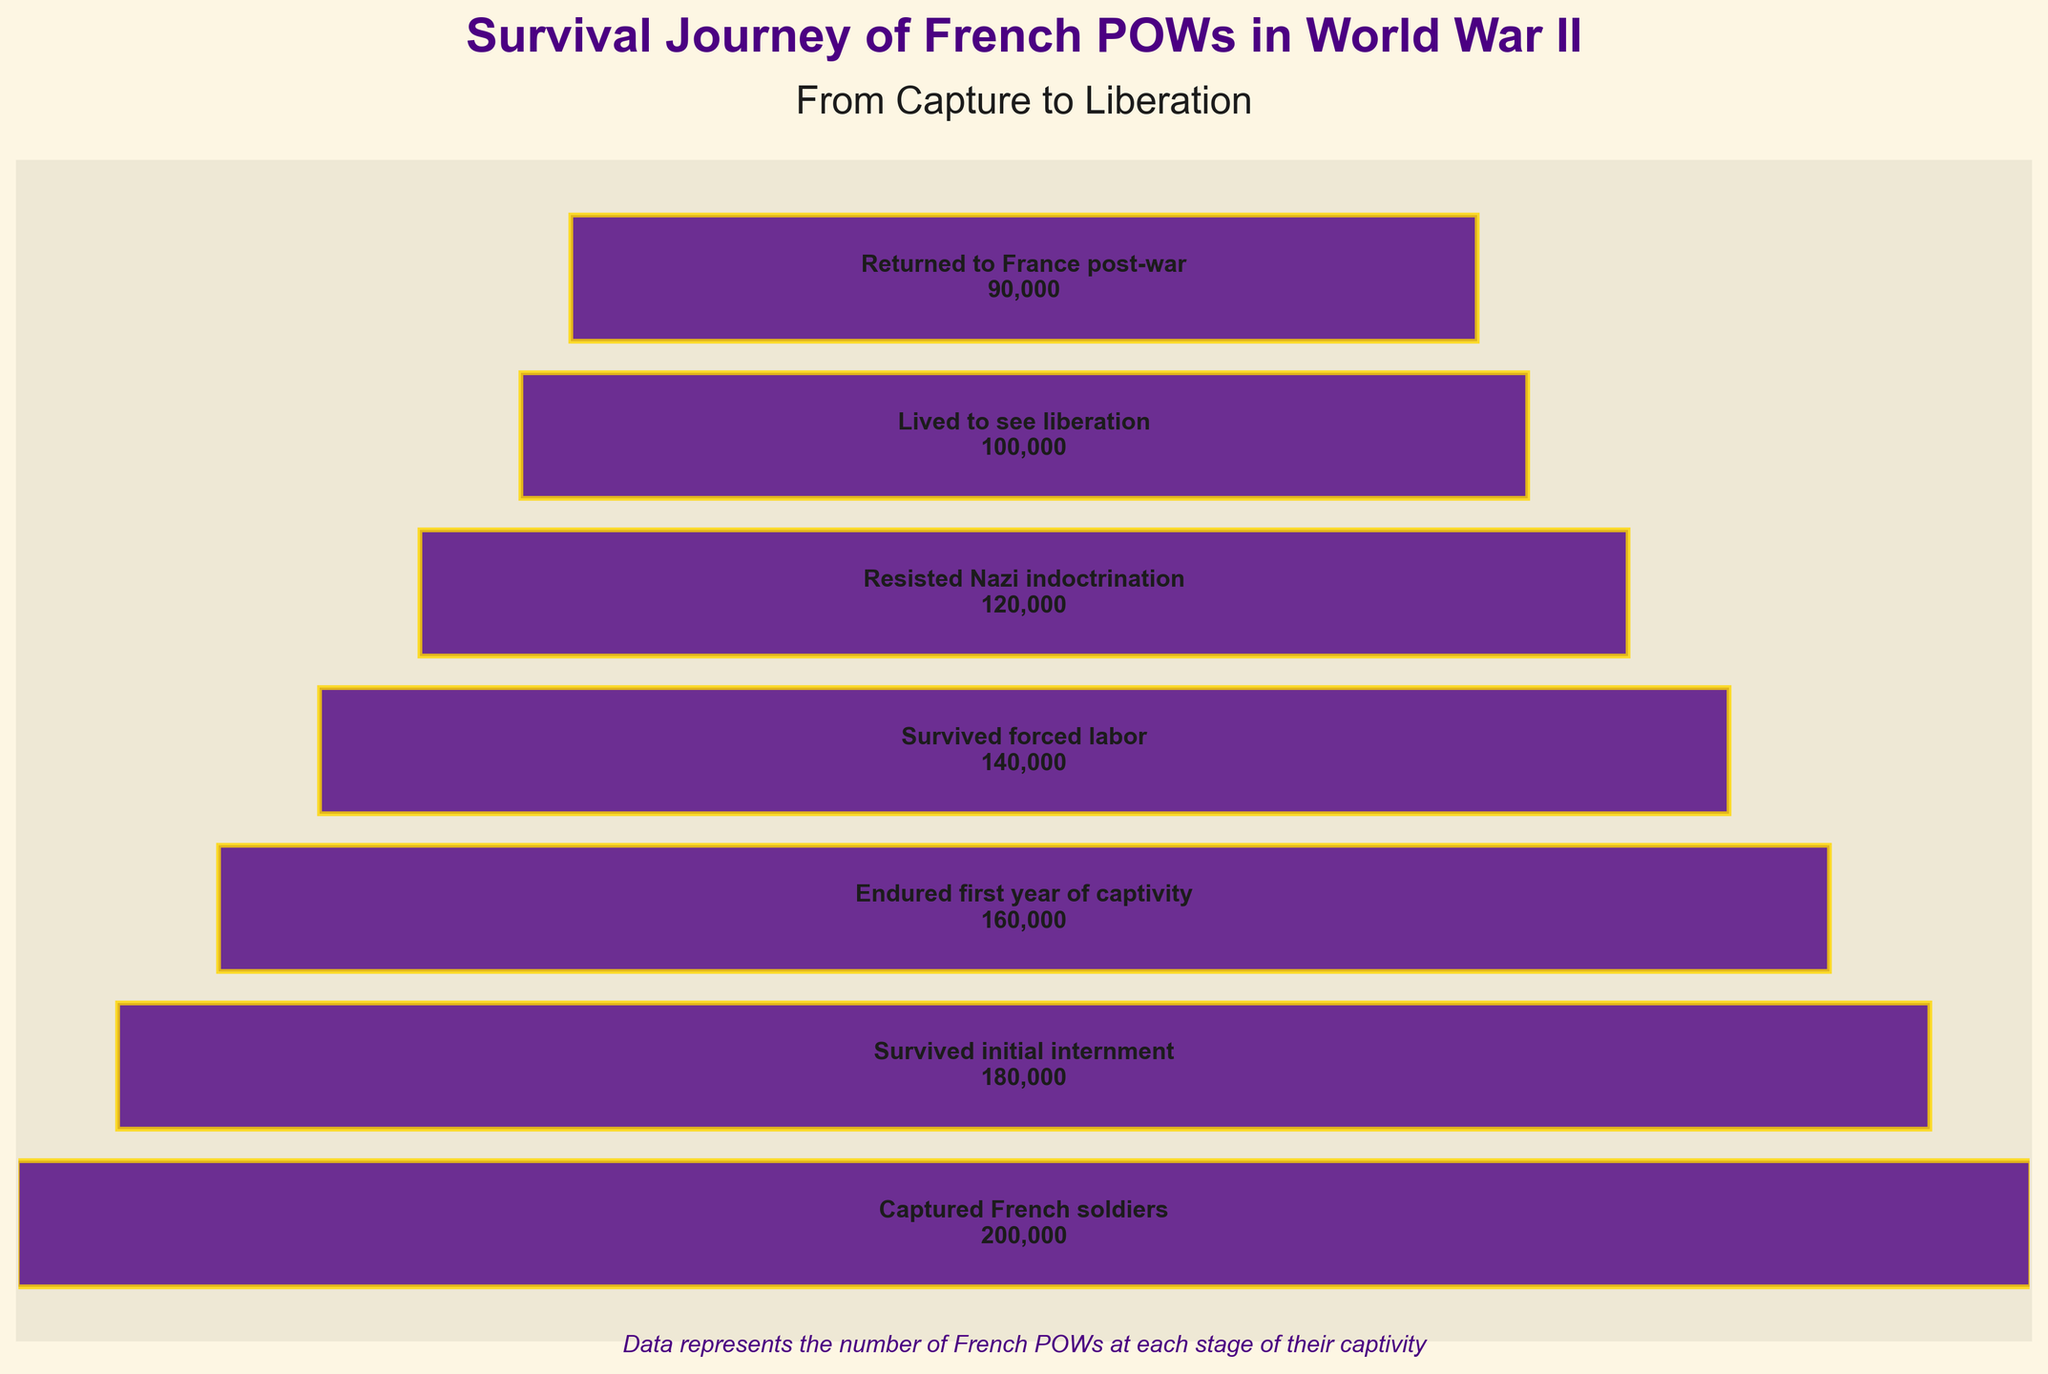What's the title of the chart? The title of the chart is typically located at the top and gives an overview of what the chart is about. For this chart, the title is prominently displayed.
Answer: Survival Journey of French POWs in World War II How many stages are shown in the funnel chart? To determine the number of stages, count the number of horizontal bars representing different stages of captivity.
Answer: 7 How many French POWs were captured? Look at the top of the funnel chart, which typically represents the initial stage. The number next to "Captured French soldiers" indicates the total at this stage.
Answer: 200,000 Which stage had the highest number of French POWs? The top stage of a funnel chart typically has the highest number because it represents the initial condition before any attrition occurs. Here, it's the "Captured French soldiers" stage.
Answer: Captured French soldiers How many French POWs survived forced labor? Locate the stage labeled "Survived forced labor" and read the number of POWs indicated next to it.
Answer: 140,000 How many fewer French POWs returned to France post-war compared to those who were captured? Subtract the number of POWs who returned to France post-war from the number who were captured. Calculation: 200,000 (captured) - 90,000 (returned) = 110,000
Answer: 110,000 What percentage of captured French soldiers survived initial internment? Divide the number of POWs who survived initial internment by the number captured, then multiply by 100. Calculation: (180,000 / 200,000) * 100 = 90%
Answer: 90% By what percentage did the number of French POWs decrease from 'Resisted Nazi indoctrination' to 'Lived to see liberation'? Compute the decrease by subtracting the number of French POWs who lived to see liberation from those who resisted Nazi indoctrination, then divide by the latter number and multiply by 100. Calculation: ((120,000 - 100,000) / 120,000) * 100 = 16.67%
Answer: 16.67% Which stage had the most significant drop in the number of POWs compared to the previous stage? Compare the differences between consecutive stages and identify the one with the highest drop. From the data: 
Endured first year of captivity to Survived forced labor: 160,000 - 140,000 = 20,000.
Survived forced labor to Resisted Nazi indoctrination: 140,000 - 120,000 = 20,000.
Resisted Nazi indoctrination to Lived to see liberation: 120,000 - 100,000 = 20,000.
The largest drop is from each of these stages equally.
Answer: Endured first year of captivity to Survived forced labor (or) Survived forced labor to Resisted Nazi indoctrination (or) Resisted Nazi indoctrination to Lived to see liberation What is the ratio of POWs who endured the first year of captivity to those who returned to France post-war? The ratio is found by dividing the number of POWs who endured the first year of captivity by those who returned to France post-war. Calculation: 160,000 / 90,000 = 1.78
Answer: 1.78 